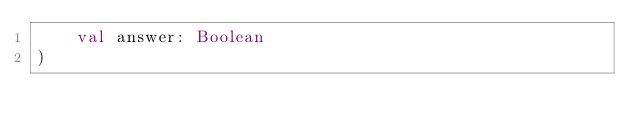Convert code to text. <code><loc_0><loc_0><loc_500><loc_500><_Kotlin_>    val answer: Boolean
)</code> 